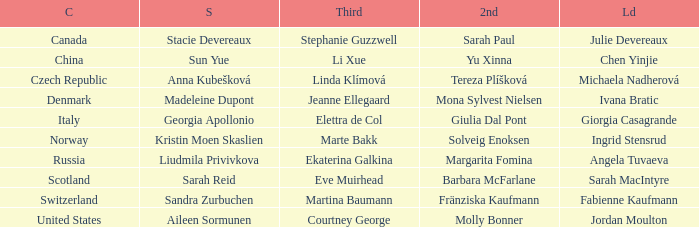What skip has switzerland as the country? Sandra Zurbuchen. 